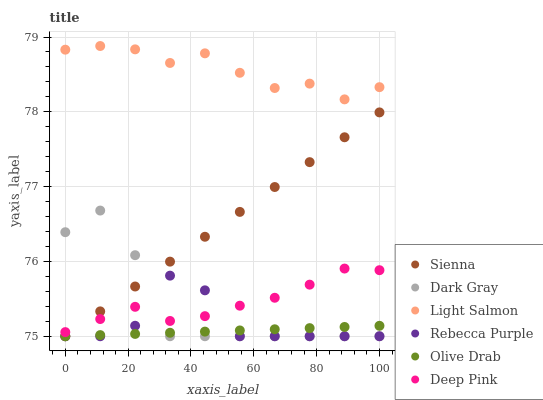Does Olive Drab have the minimum area under the curve?
Answer yes or no. Yes. Does Light Salmon have the maximum area under the curve?
Answer yes or no. Yes. Does Deep Pink have the minimum area under the curve?
Answer yes or no. No. Does Deep Pink have the maximum area under the curve?
Answer yes or no. No. Is Olive Drab the smoothest?
Answer yes or no. Yes. Is Rebecca Purple the roughest?
Answer yes or no. Yes. Is Light Salmon the smoothest?
Answer yes or no. No. Is Light Salmon the roughest?
Answer yes or no. No. Does Dark Gray have the lowest value?
Answer yes or no. Yes. Does Deep Pink have the lowest value?
Answer yes or no. No. Does Light Salmon have the highest value?
Answer yes or no. Yes. Does Deep Pink have the highest value?
Answer yes or no. No. Is Dark Gray less than Light Salmon?
Answer yes or no. Yes. Is Light Salmon greater than Deep Pink?
Answer yes or no. Yes. Does Dark Gray intersect Sienna?
Answer yes or no. Yes. Is Dark Gray less than Sienna?
Answer yes or no. No. Is Dark Gray greater than Sienna?
Answer yes or no. No. Does Dark Gray intersect Light Salmon?
Answer yes or no. No. 